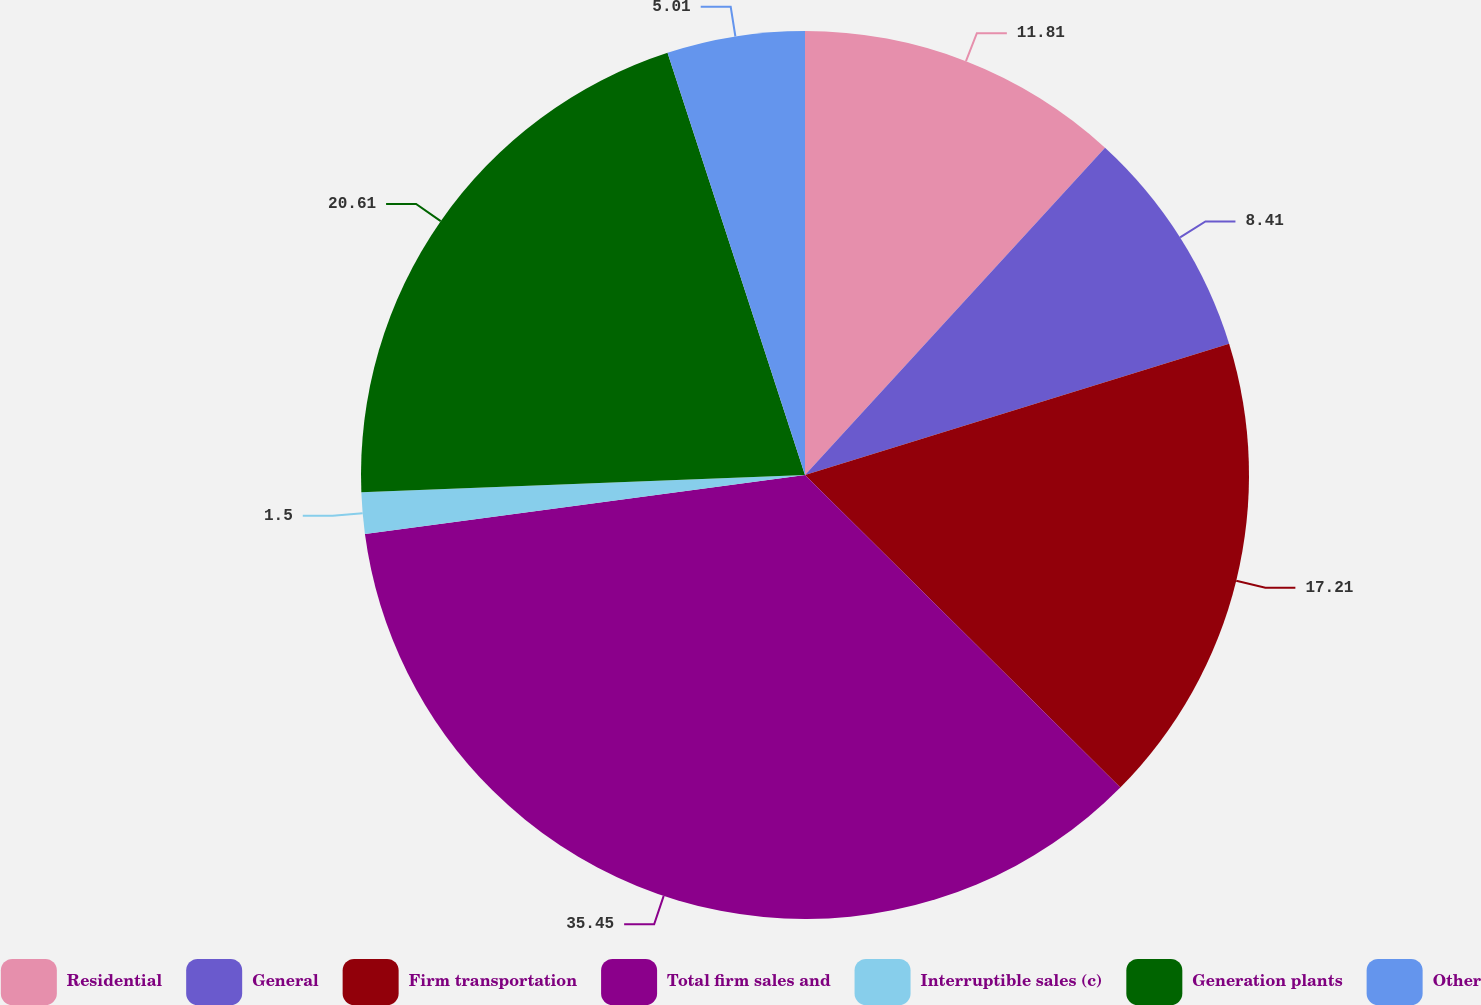Convert chart to OTSL. <chart><loc_0><loc_0><loc_500><loc_500><pie_chart><fcel>Residential<fcel>General<fcel>Firm transportation<fcel>Total firm sales and<fcel>Interruptible sales (c)<fcel>Generation plants<fcel>Other<nl><fcel>11.81%<fcel>8.41%<fcel>17.21%<fcel>35.45%<fcel>1.5%<fcel>20.61%<fcel>5.01%<nl></chart> 